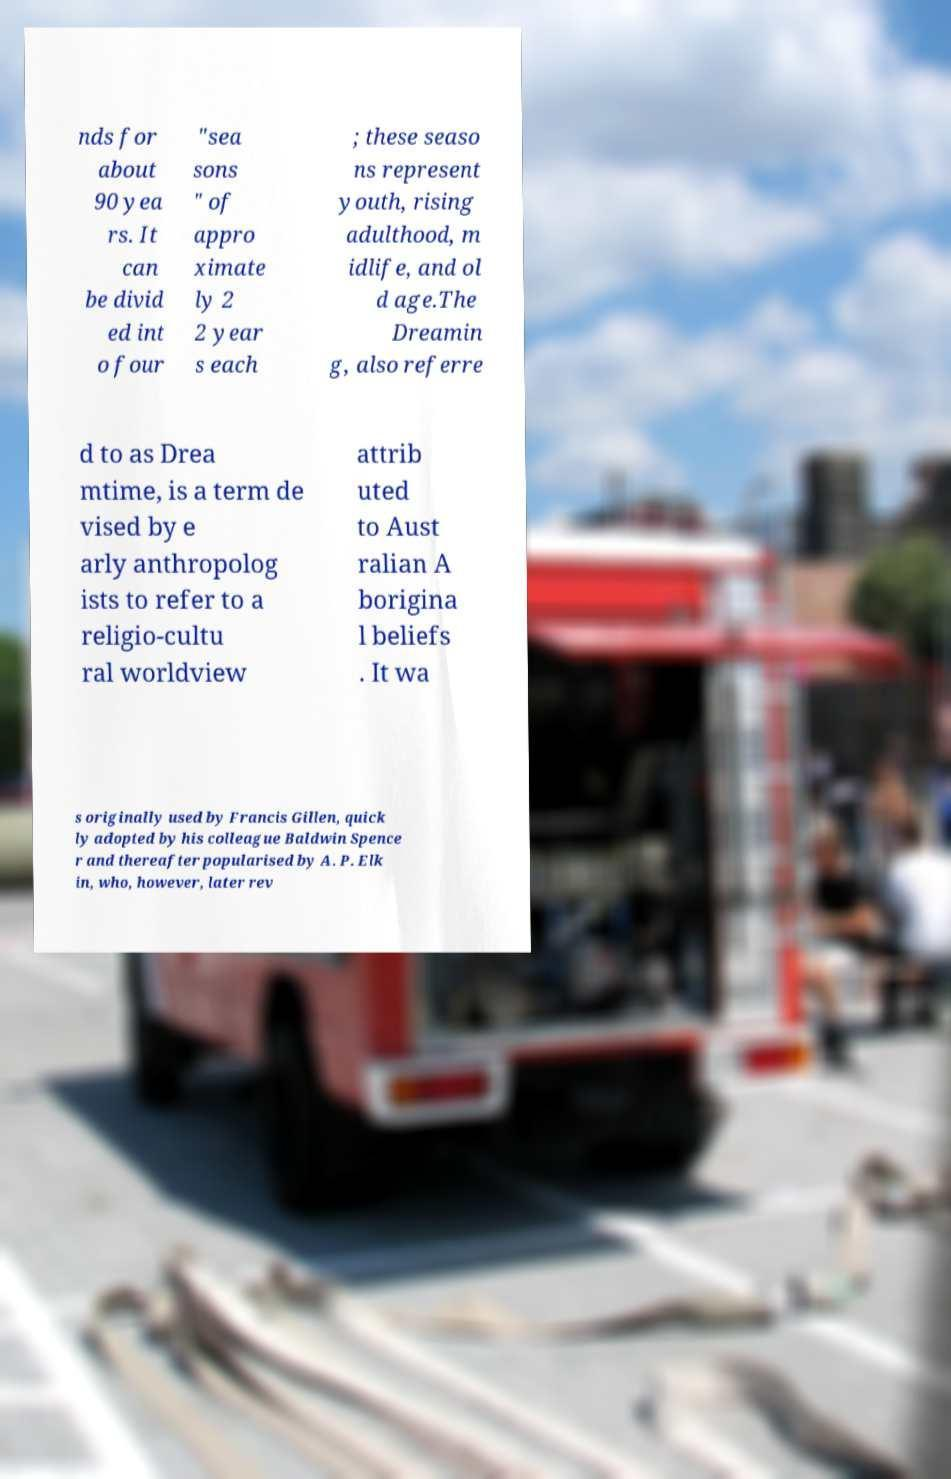Can you read and provide the text displayed in the image?This photo seems to have some interesting text. Can you extract and type it out for me? nds for about 90 yea rs. It can be divid ed int o four "sea sons " of appro ximate ly 2 2 year s each ; these seaso ns represent youth, rising adulthood, m idlife, and ol d age.The Dreamin g, also referre d to as Drea mtime, is a term de vised by e arly anthropolog ists to refer to a religio-cultu ral worldview attrib uted to Aust ralian A borigina l beliefs . It wa s originally used by Francis Gillen, quick ly adopted by his colleague Baldwin Spence r and thereafter popularised by A. P. Elk in, who, however, later rev 